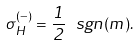Convert formula to latex. <formula><loc_0><loc_0><loc_500><loc_500>\sigma _ { H } ^ { ( - ) } = \frac { 1 } { 2 } \, \ s g n ( m ) .</formula> 